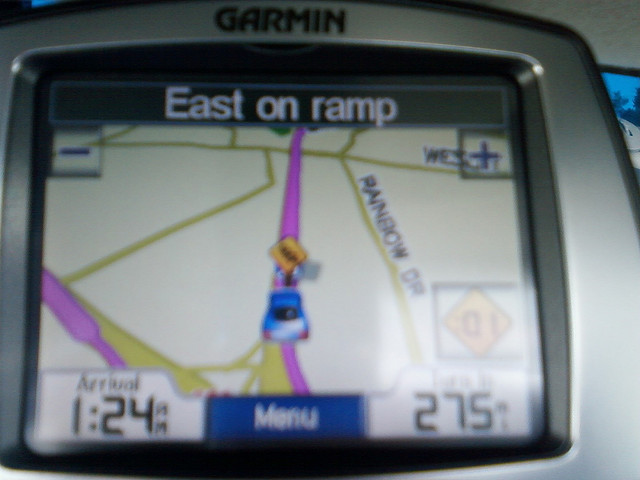Identify and read out the text in this image. GARMIN East on ramp RAINBOW west 275 Menu 1:24 